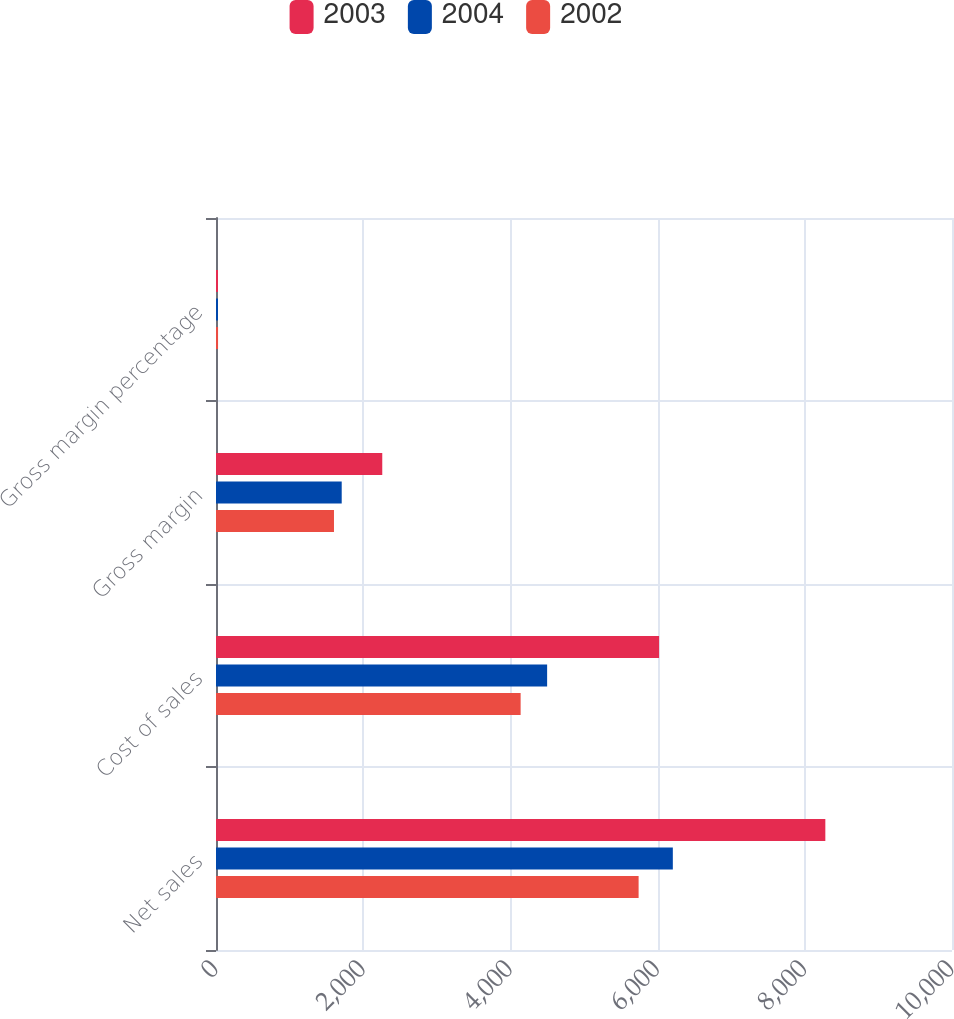Convert chart. <chart><loc_0><loc_0><loc_500><loc_500><stacked_bar_chart><ecel><fcel>Net sales<fcel>Cost of sales<fcel>Gross margin<fcel>Gross margin percentage<nl><fcel>2003<fcel>8279<fcel>6020<fcel>2259<fcel>27.3<nl><fcel>2004<fcel>6207<fcel>4499<fcel>1708<fcel>27.5<nl><fcel>2002<fcel>5742<fcel>4139<fcel>1603<fcel>27.9<nl></chart> 